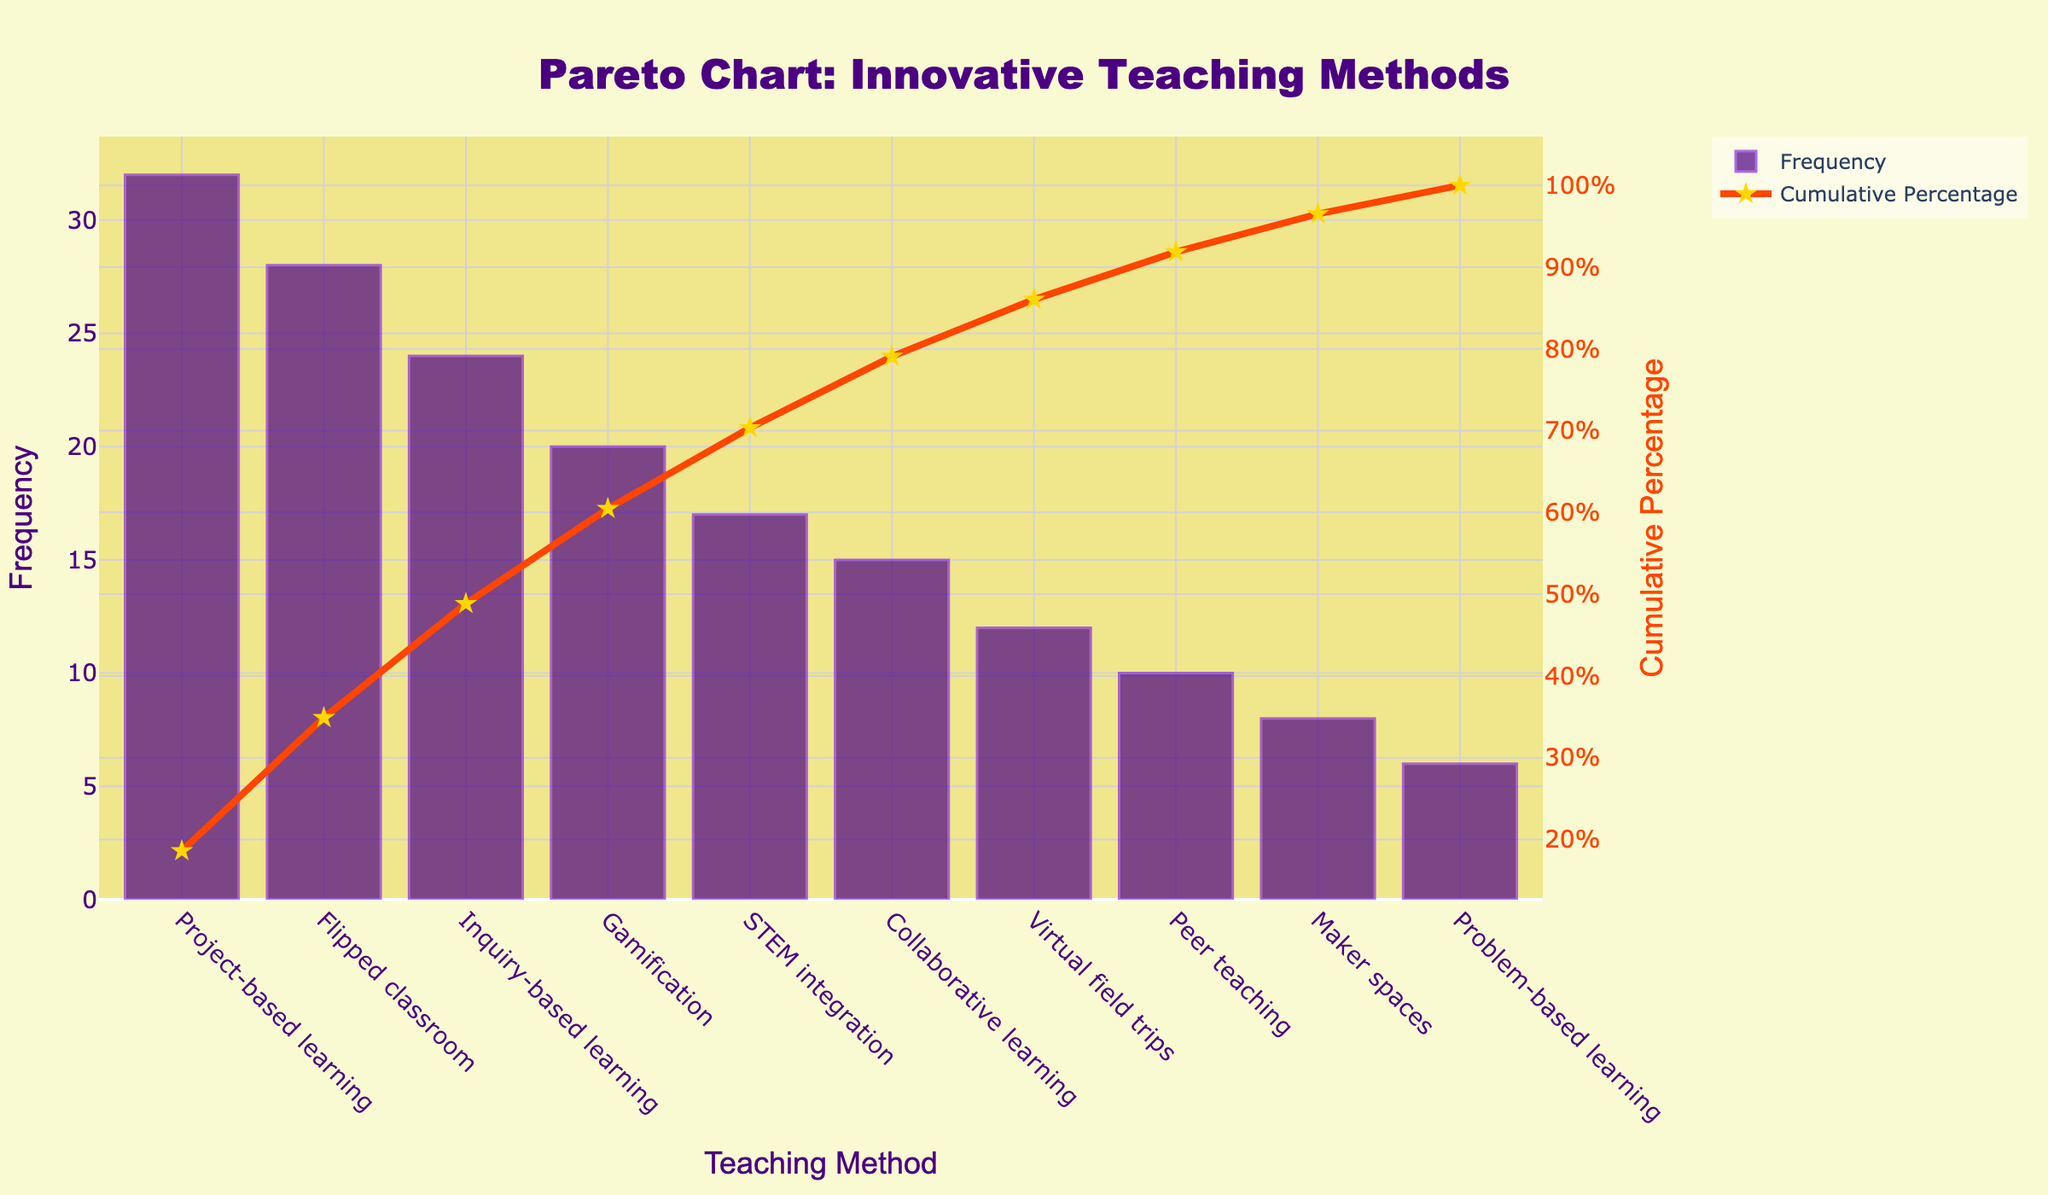What is the title of the chart? The title appears at the top of the chart and is "Pareto Chart: Innovative Teaching Methods". This provides a clear indication of what the chart is about.
Answer: Pareto Chart: Innovative Teaching Methods Which teaching method has the highest frequency of implementation? The bar chart shows that 'Project-based learning' has the tallest bar, indicating it has the highest frequency of implementation.
Answer: Project-based learning What is the frequency of 'Gamification'? By looking at the height of the bar corresponding to 'Gamification', it reaches up to 20 on the y-axis that represents frequency.
Answer: 20 How many teaching methods have a frequency of implementation greater than 20? Observing the bar chart, only 'Project-based learning' (32), 'Flipped classroom' (28), and 'Inquiry-based learning' (24) have frequencies greater than 20.
Answer: 3 What is the cumulative percentage of 'Gamification'? Referring to the line chart, the point directly above 'Gamification' shows a cumulative percentage around 65%.
Answer: 65% Which teaching method contributes to reaching approximately 85% of the cumulative percentage? By following the cumulative percentage line to around 85%, the 'STEM integration' teaching method corresponds to this percentage.
Answer: STEM integration What is the combined frequency of 'Collaborative learning' and 'Virtual field trips'? The frequency of 'Collaborative learning' is 15 and 'Virtual field trips' is 12. Adding them together gives 15 + 12 = 27.
Answer: 27 How many methods need to be applied to achieve over 75% cumulative percentage? Looking at the cumulative percentage, 'Gamification' marks around 75%, so four methods (Project-based learning, Flipped classroom, Inquiry-based learning, and Gamification) combine to achieve over 75%.
Answer: 4 Which teaching method has a cumulative percentage just above 50%? The cumulative percentage line shows that just above 50% corresponds to 'Inquiry-based learning'.
Answer: Inquiry-based learning What is the difference in frequency between the most and least implemented teaching methods? 'Project-based learning' has the highest frequency at 32, and 'Problem-based learning' has the lowest at 6. The difference is 32 - 6 = 26.
Answer: 26 